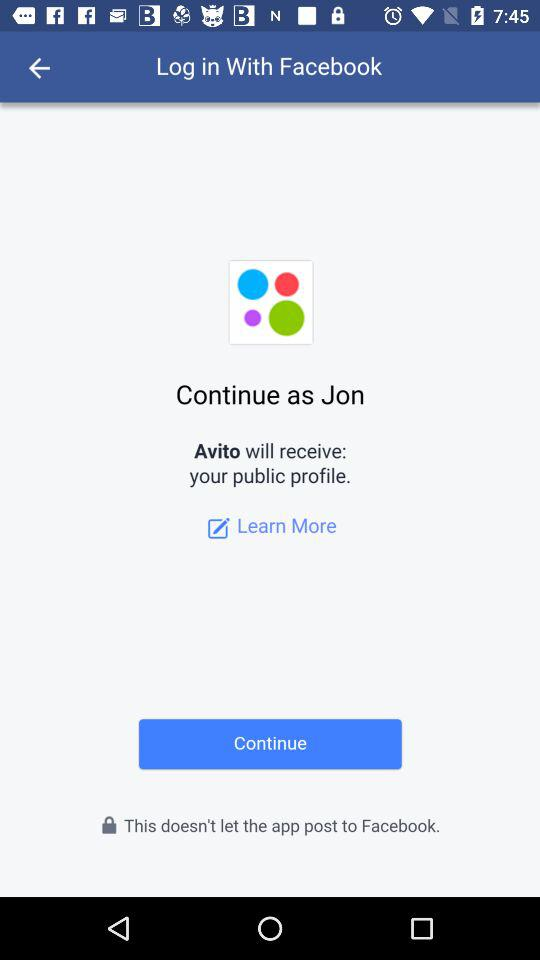What application are we accessing? The application we are accessing is "Avito". 